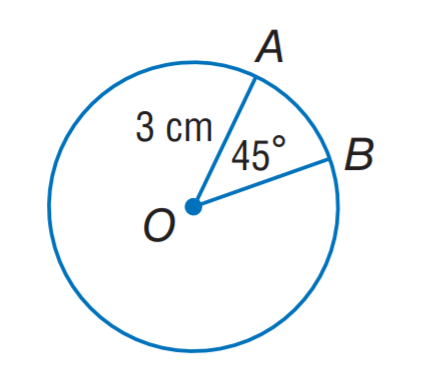Question: Find the length of \widehat A B. Round to the nearest hundredth.
Choices:
A. 1.18
B. 2.36
C. 3.36
D. 4.72
Answer with the letter. Answer: B 